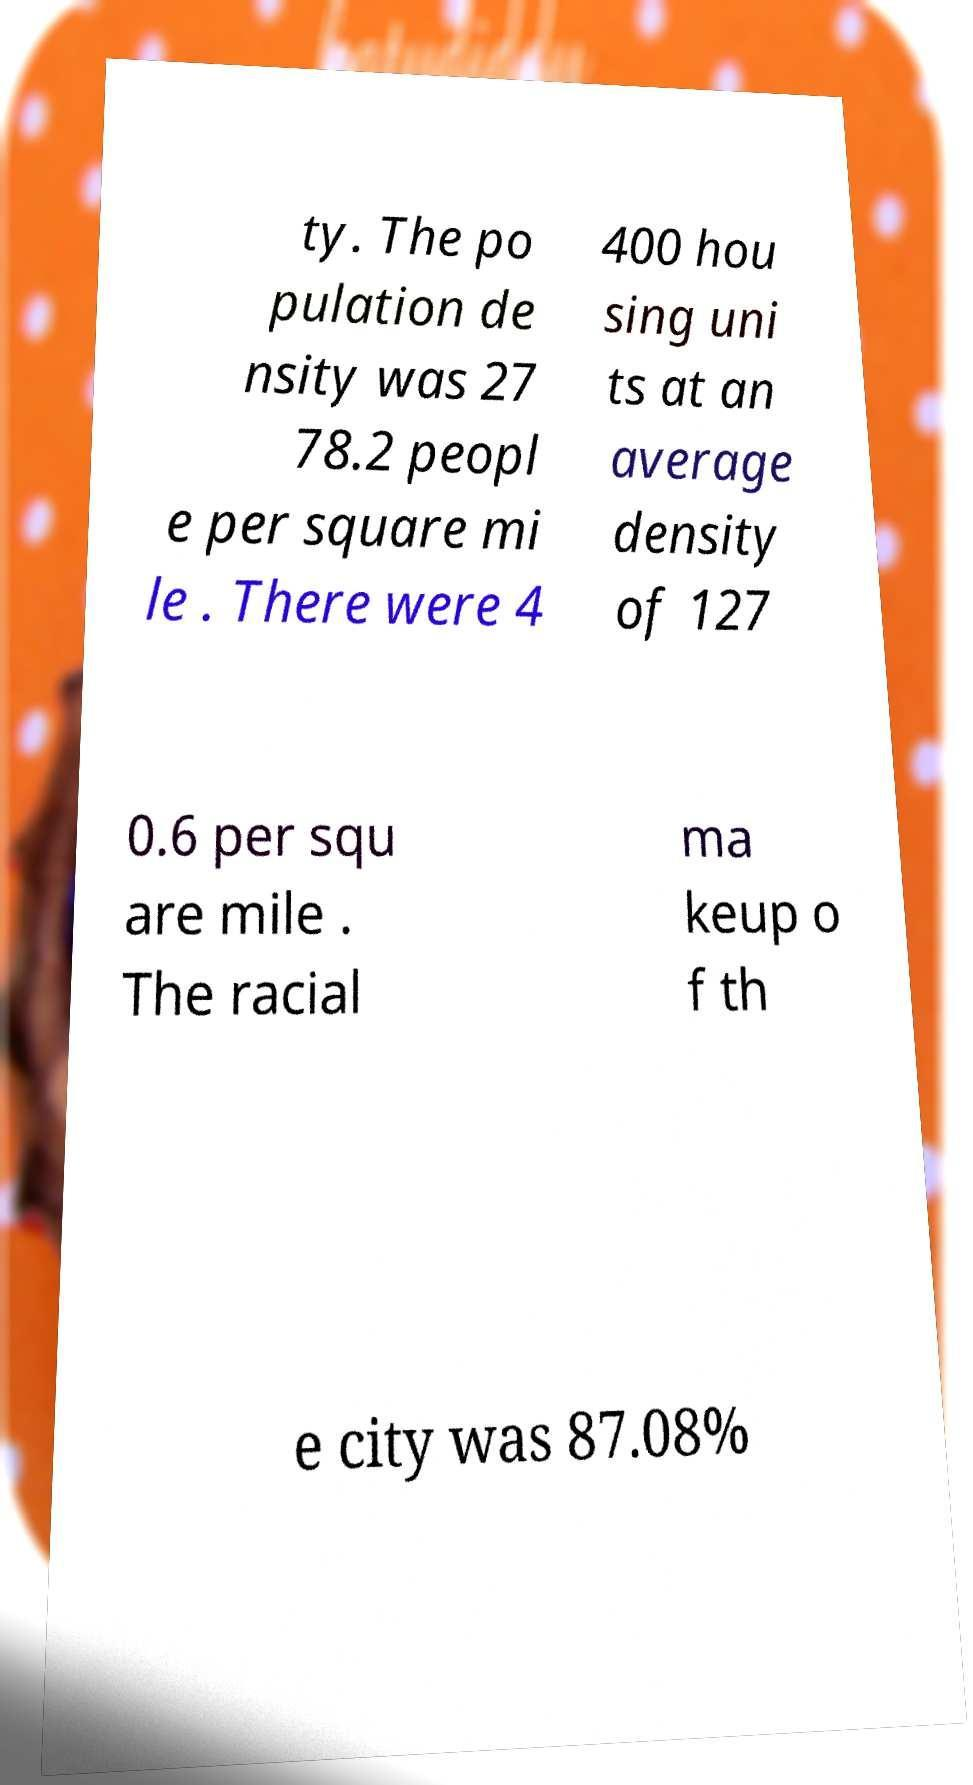For documentation purposes, I need the text within this image transcribed. Could you provide that? ty. The po pulation de nsity was 27 78.2 peopl e per square mi le . There were 4 400 hou sing uni ts at an average density of 127 0.6 per squ are mile . The racial ma keup o f th e city was 87.08% 